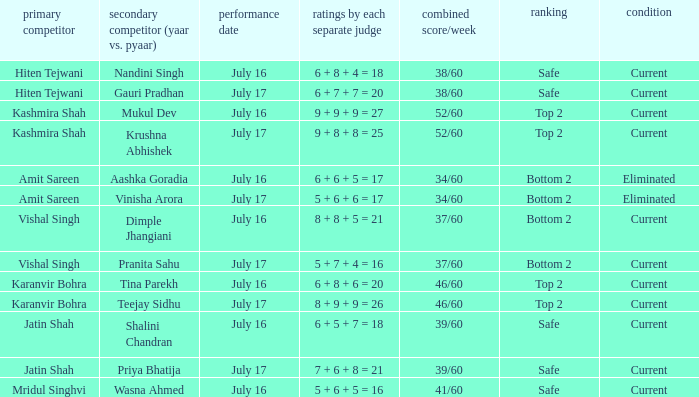Write the full table. {'header': ['primary competitor', 'secondary competitor (yaar vs. pyaar)', 'performance date', 'ratings by each separate judge', 'combined score/week', 'ranking', 'condition'], 'rows': [['Hiten Tejwani', 'Nandini Singh', 'July 16', '6 + 8 + 4 = 18', '38/60', 'Safe', 'Current'], ['Hiten Tejwani', 'Gauri Pradhan', 'July 17', '6 + 7 + 7 = 20', '38/60', 'Safe', 'Current'], ['Kashmira Shah', 'Mukul Dev', 'July 16', '9 + 9 + 9 = 27', '52/60', 'Top 2', 'Current'], ['Kashmira Shah', 'Krushna Abhishek', 'July 17', '9 + 8 + 8 = 25', '52/60', 'Top 2', 'Current'], ['Amit Sareen', 'Aashka Goradia', 'July 16', '6 + 6 + 5 = 17', '34/60', 'Bottom 2', 'Eliminated'], ['Amit Sareen', 'Vinisha Arora', 'July 17', '5 + 6 + 6 = 17', '34/60', 'Bottom 2', 'Eliminated'], ['Vishal Singh', 'Dimple Jhangiani', 'July 16', '8 + 8 + 5 = 21', '37/60', 'Bottom 2', 'Current'], ['Vishal Singh', 'Pranita Sahu', 'July 17', '5 + 7 + 4 = 16', '37/60', 'Bottom 2', 'Current'], ['Karanvir Bohra', 'Tina Parekh', 'July 16', '6 + 8 + 6 = 20', '46/60', 'Top 2', 'Current'], ['Karanvir Bohra', 'Teejay Sidhu', 'July 17', '8 + 9 + 9 = 26', '46/60', 'Top 2', 'Current'], ['Jatin Shah', 'Shalini Chandran', 'July 16', '6 + 5 + 7 = 18', '39/60', 'Safe', 'Current'], ['Jatin Shah', 'Priya Bhatija', 'July 17', '7 + 6 + 8 = 21', '39/60', 'Safe', 'Current'], ['Mridul Singhvi', 'Wasna Ahmed', 'July 16', '5 + 6 + 5 = 16', '41/60', 'Safe', 'Current']]} Who performed with Tina Parekh? Karanvir Bohra. 